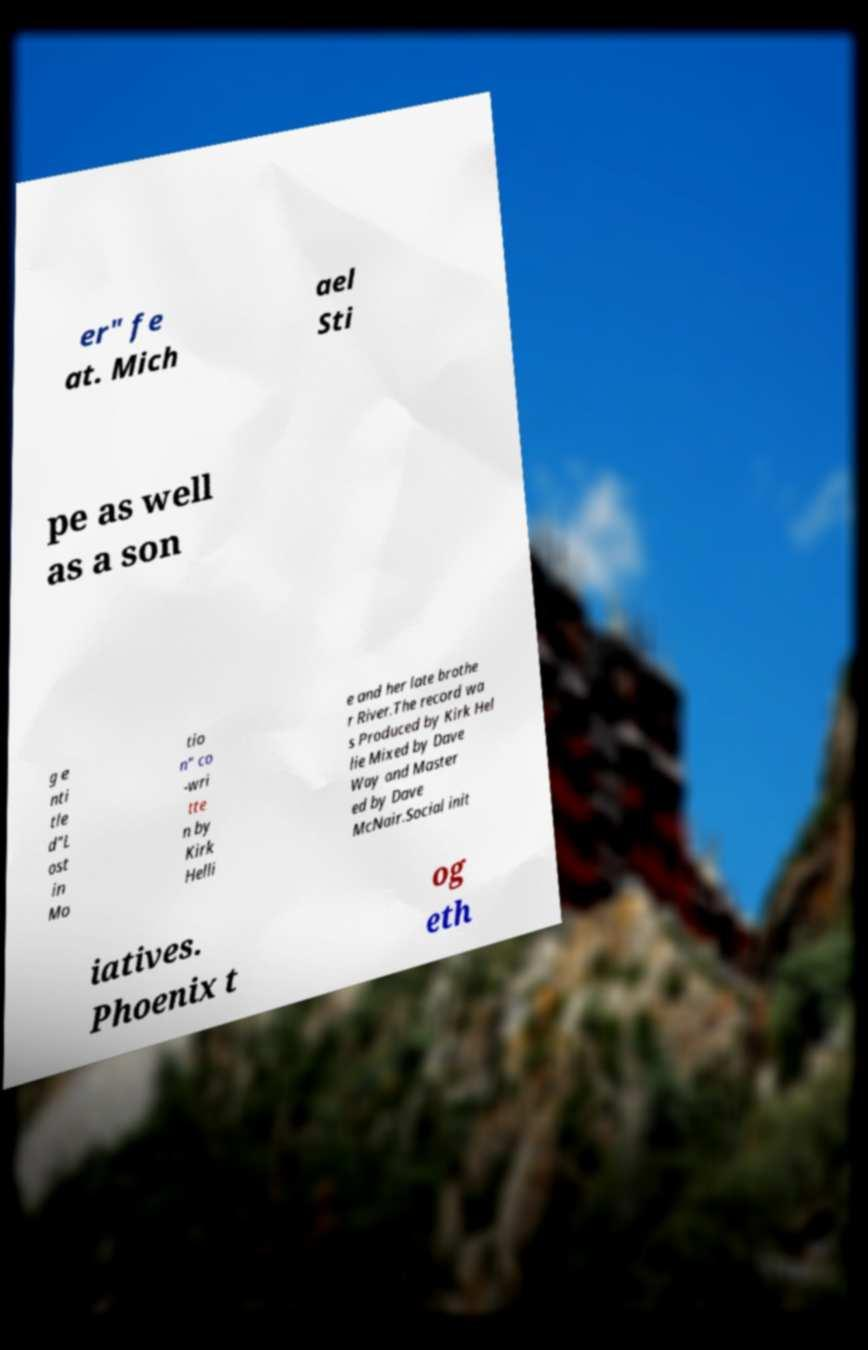Could you extract and type out the text from this image? er" fe at. Mich ael Sti pe as well as a son g e nti tle d"L ost in Mo tio n" co -wri tte n by Kirk Helli e and her late brothe r River.The record wa s Produced by Kirk Hel lie Mixed by Dave Way and Master ed by Dave McNair.Social init iatives. Phoenix t og eth 